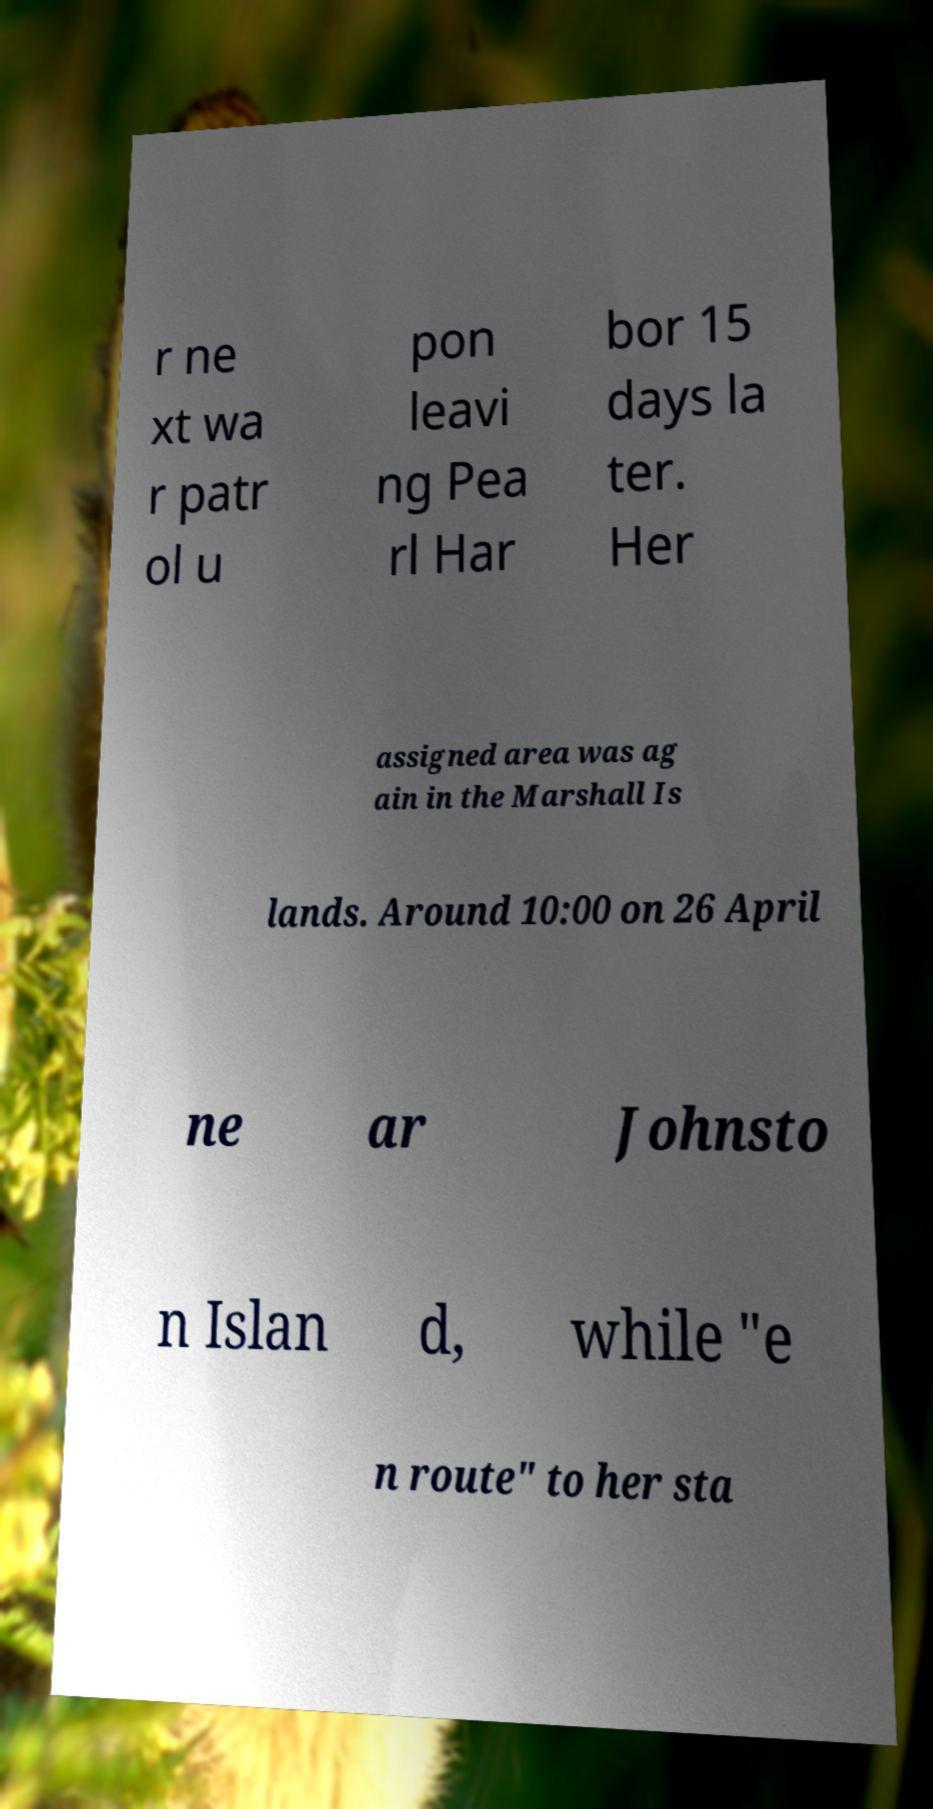I need the written content from this picture converted into text. Can you do that? r ne xt wa r patr ol u pon leavi ng Pea rl Har bor 15 days la ter. Her assigned area was ag ain in the Marshall Is lands. Around 10:00 on 26 April ne ar Johnsto n Islan d, while "e n route" to her sta 